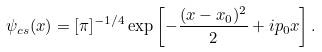Convert formula to latex. <formula><loc_0><loc_0><loc_500><loc_500>\psi _ { c s } ( x ) = [ \pi ] ^ { - 1 / 4 } \exp \left [ - \frac { ( x - x _ { 0 } ) ^ { 2 } } { 2 } + i p _ { 0 } x \right ] .</formula> 